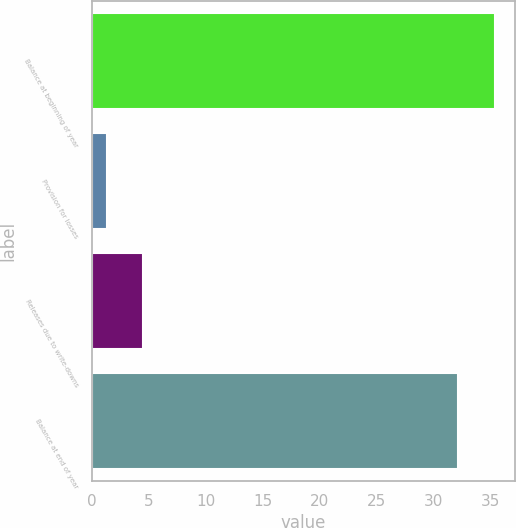Convert chart to OTSL. <chart><loc_0><loc_0><loc_500><loc_500><bar_chart><fcel>Balance at beginning of year<fcel>Provision for losses<fcel>Releases due to write-downs<fcel>Balance at end of year<nl><fcel>35.39<fcel>1.3<fcel>4.49<fcel>32.2<nl></chart> 